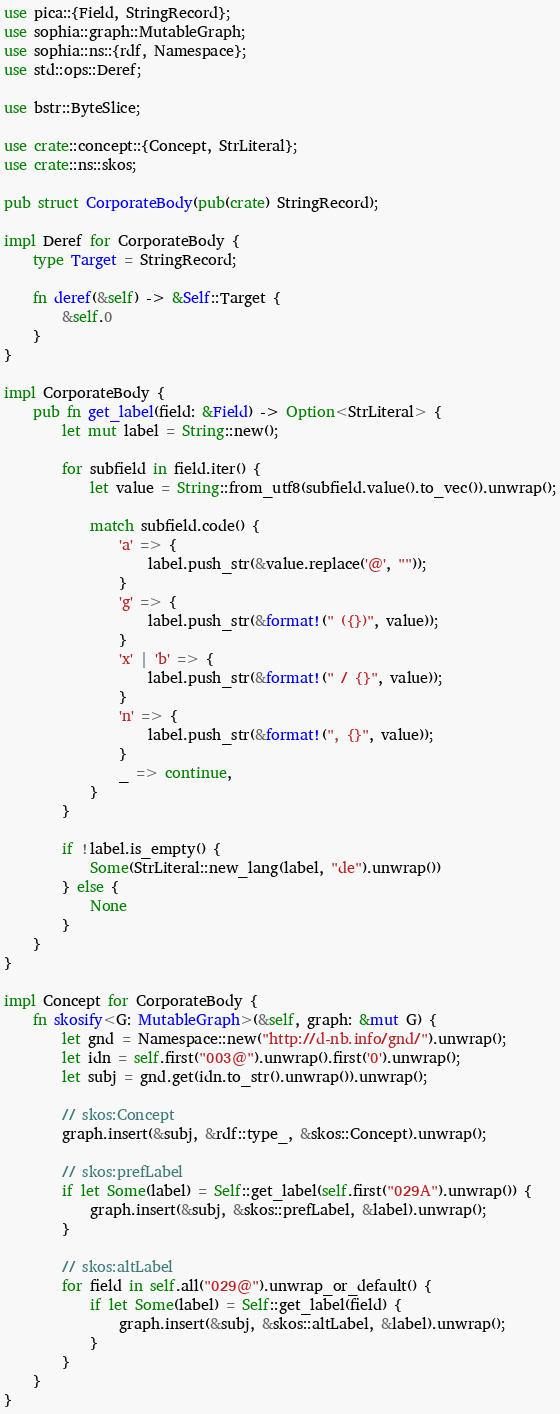<code> <loc_0><loc_0><loc_500><loc_500><_Rust_>use pica::{Field, StringRecord};
use sophia::graph::MutableGraph;
use sophia::ns::{rdf, Namespace};
use std::ops::Deref;

use bstr::ByteSlice;

use crate::concept::{Concept, StrLiteral};
use crate::ns::skos;

pub struct CorporateBody(pub(crate) StringRecord);

impl Deref for CorporateBody {
    type Target = StringRecord;

    fn deref(&self) -> &Self::Target {
        &self.0
    }
}

impl CorporateBody {
    pub fn get_label(field: &Field) -> Option<StrLiteral> {
        let mut label = String::new();

        for subfield in field.iter() {
            let value = String::from_utf8(subfield.value().to_vec()).unwrap();

            match subfield.code() {
                'a' => {
                    label.push_str(&value.replace('@', ""));
                }
                'g' => {
                    label.push_str(&format!(" ({})", value));
                }
                'x' | 'b' => {
                    label.push_str(&format!(" / {}", value));
                }
                'n' => {
                    label.push_str(&format!(", {}", value));
                }
                _ => continue,
            }
        }

        if !label.is_empty() {
            Some(StrLiteral::new_lang(label, "de").unwrap())
        } else {
            None
        }
    }
}

impl Concept for CorporateBody {
    fn skosify<G: MutableGraph>(&self, graph: &mut G) {
        let gnd = Namespace::new("http://d-nb.info/gnd/").unwrap();
        let idn = self.first("003@").unwrap().first('0').unwrap();
        let subj = gnd.get(idn.to_str().unwrap()).unwrap();

        // skos:Concept
        graph.insert(&subj, &rdf::type_, &skos::Concept).unwrap();

        // skos:prefLabel
        if let Some(label) = Self::get_label(self.first("029A").unwrap()) {
            graph.insert(&subj, &skos::prefLabel, &label).unwrap();
        }

        // skos:altLabel
        for field in self.all("029@").unwrap_or_default() {
            if let Some(label) = Self::get_label(field) {
                graph.insert(&subj, &skos::altLabel, &label).unwrap();
            }
        }
    }
}
</code> 